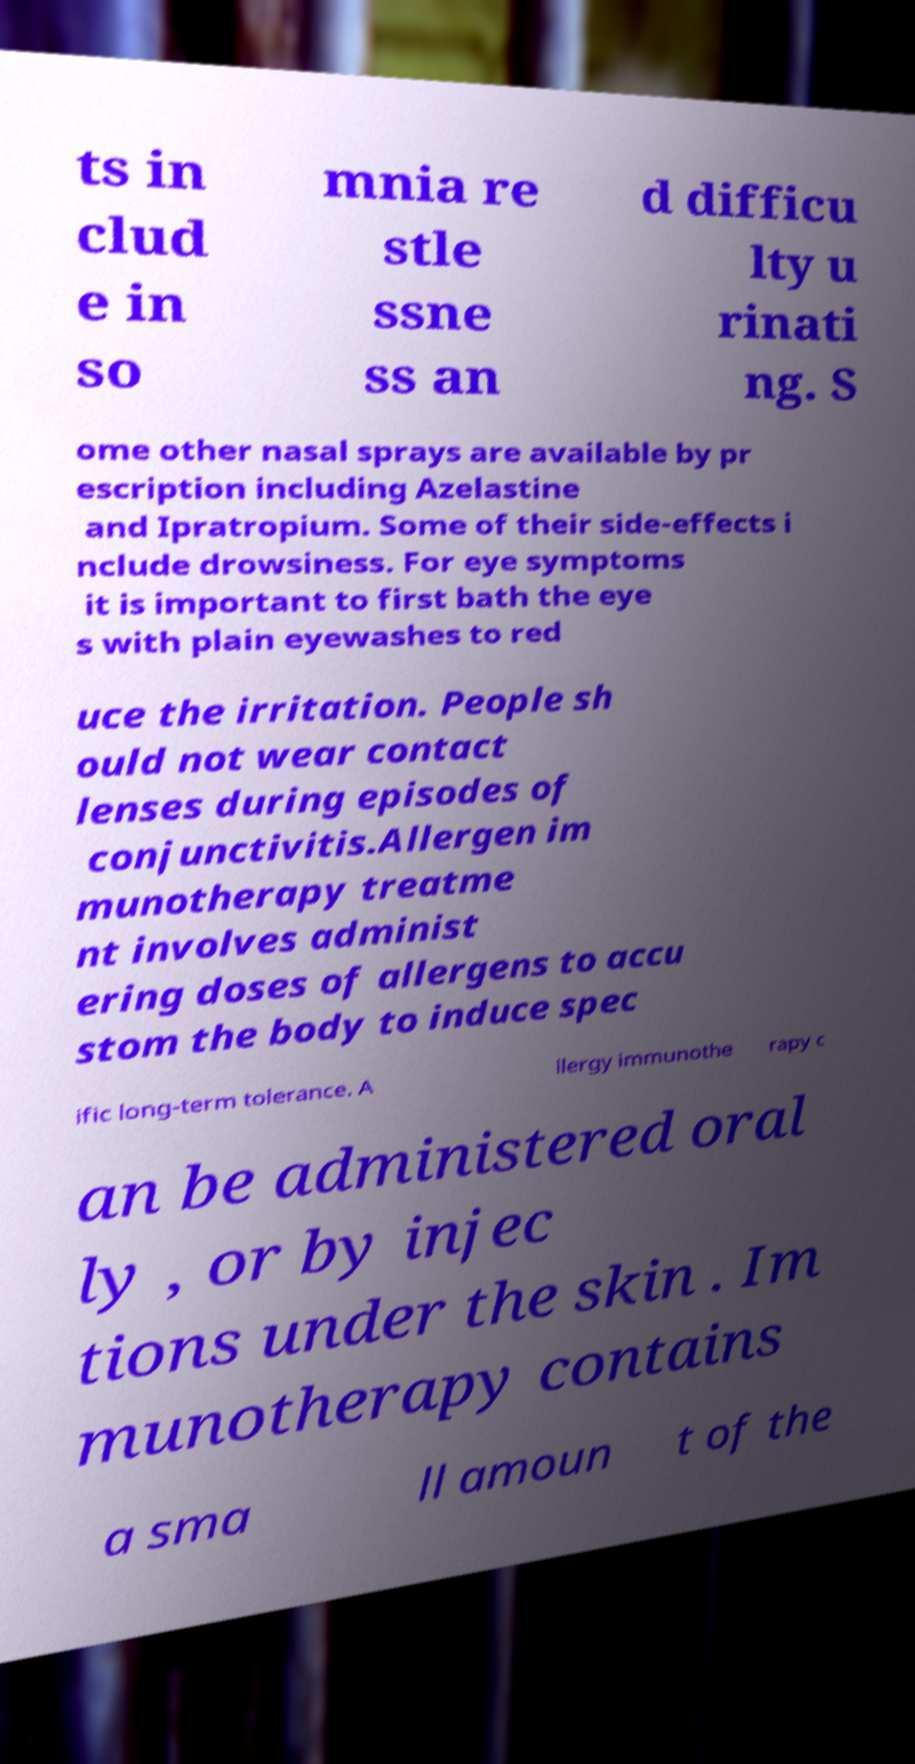Can you accurately transcribe the text from the provided image for me? ts in clud e in so mnia re stle ssne ss an d difficu lty u rinati ng. S ome other nasal sprays are available by pr escription including Azelastine and Ipratropium. Some of their side-effects i nclude drowsiness. For eye symptoms it is important to first bath the eye s with plain eyewashes to red uce the irritation. People sh ould not wear contact lenses during episodes of conjunctivitis.Allergen im munotherapy treatme nt involves administ ering doses of allergens to accu stom the body to induce spec ific long-term tolerance. A llergy immunothe rapy c an be administered oral ly , or by injec tions under the skin . Im munotherapy contains a sma ll amoun t of the 